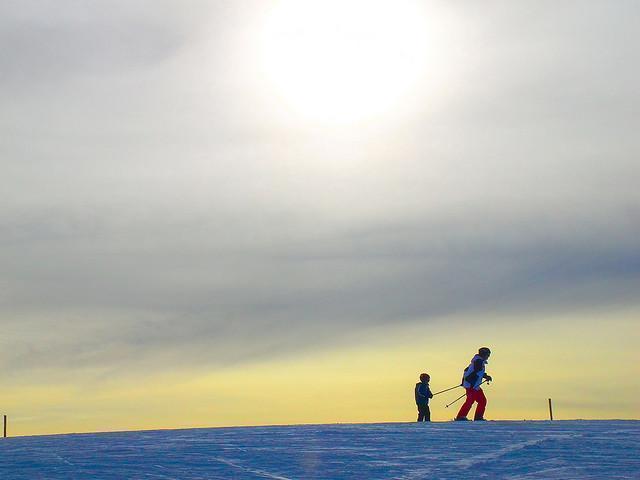What is the father doing with the child out on the mountain?
Indicate the correct choice and explain in the format: 'Answer: answer
Rationale: rationale.'
Options: Teaching, transporting, pulling, hunting. Answer: teaching.
Rationale: The child is small and likely does not know how to ski yet. 